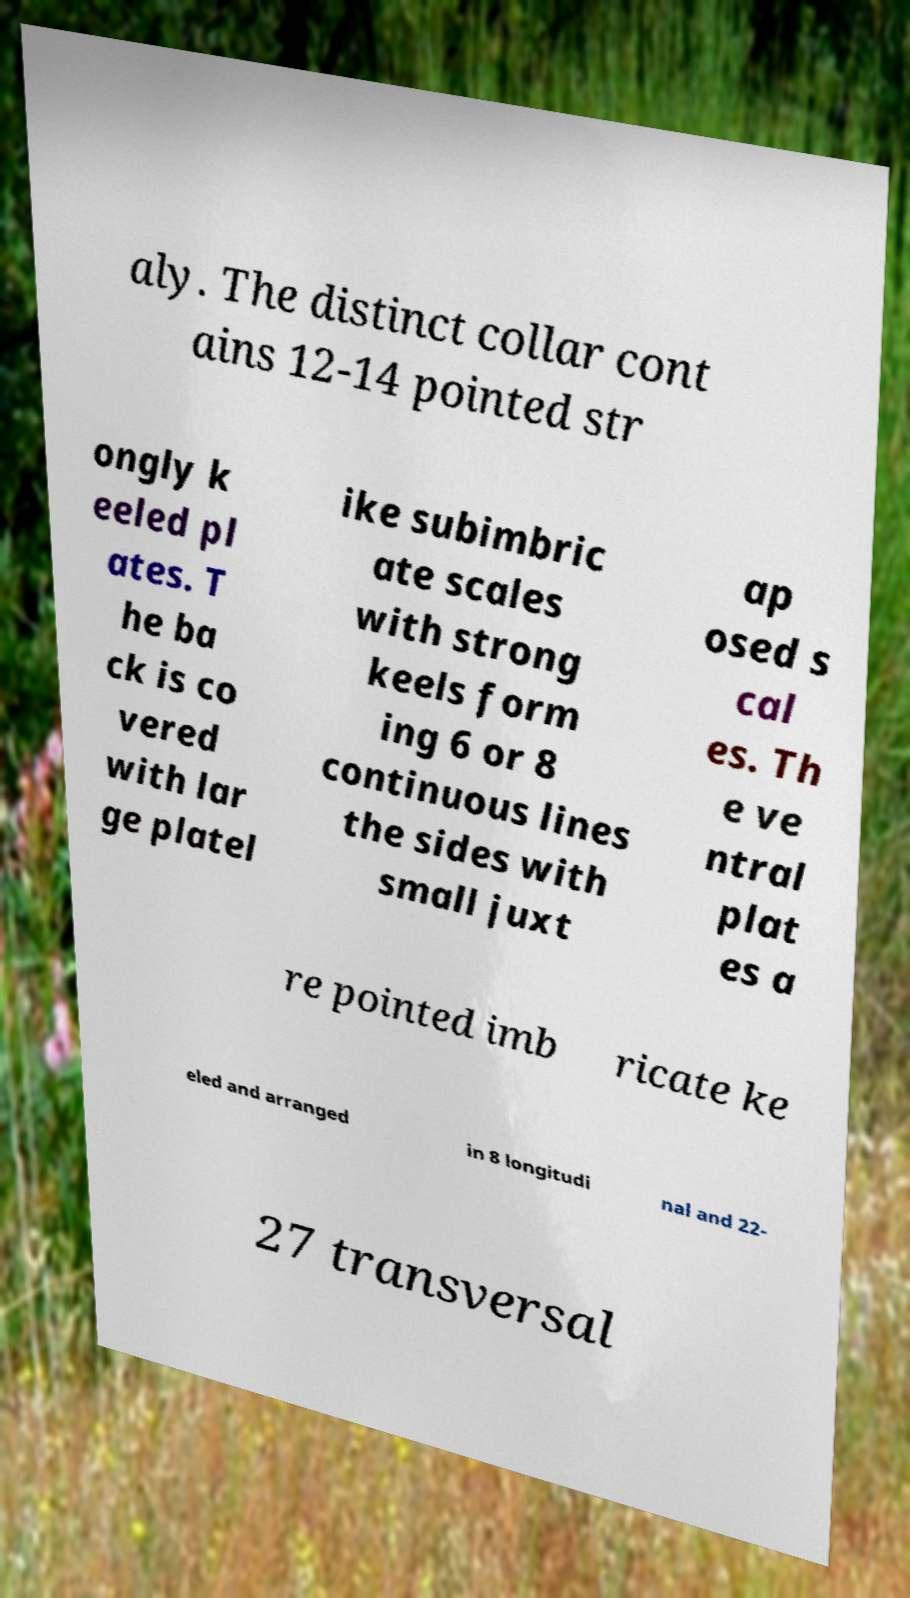For documentation purposes, I need the text within this image transcribed. Could you provide that? aly. The distinct collar cont ains 12-14 pointed str ongly k eeled pl ates. T he ba ck is co vered with lar ge platel ike subimbric ate scales with strong keels form ing 6 or 8 continuous lines the sides with small juxt ap osed s cal es. Th e ve ntral plat es a re pointed imb ricate ke eled and arranged in 8 longitudi nal and 22- 27 transversal 